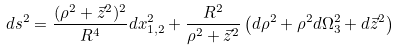<formula> <loc_0><loc_0><loc_500><loc_500>d s ^ { 2 } = \frac { ( \rho ^ { 2 } + \vec { z } ^ { 2 } ) ^ { 2 } } { R ^ { 4 } } d x ^ { 2 } _ { 1 , 2 } + \frac { R ^ { 2 } } { \rho ^ { 2 } + \vec { z } ^ { 2 } } \left ( d \rho ^ { 2 } + \rho ^ { 2 } d \Omega _ { 3 } ^ { 2 } + d \vec { z } ^ { 2 } \right )</formula> 